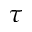<formula> <loc_0><loc_0><loc_500><loc_500>\tau</formula> 